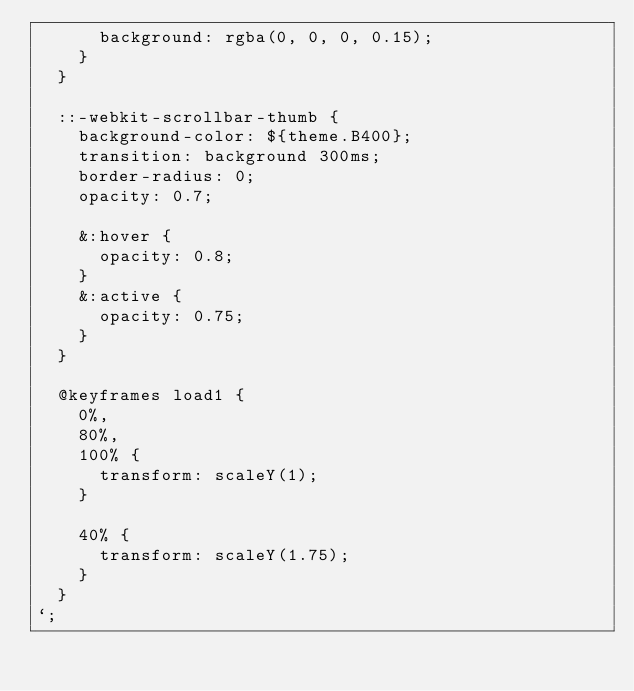<code> <loc_0><loc_0><loc_500><loc_500><_JavaScript_>      background: rgba(0, 0, 0, 0.15);
    }
  }

  ::-webkit-scrollbar-thumb {
    background-color: ${theme.B400};
    transition: background 300ms;
    border-radius: 0;
    opacity: 0.7;

    &:hover {
      opacity: 0.8;
    }
    &:active {
      opacity: 0.75;
    }
  }

  @keyframes load1 {
    0%,
    80%,
    100% {
      transform: scaleY(1);
    }
    
    40% {
      transform: scaleY(1.75);
    }
  }
`;
</code> 